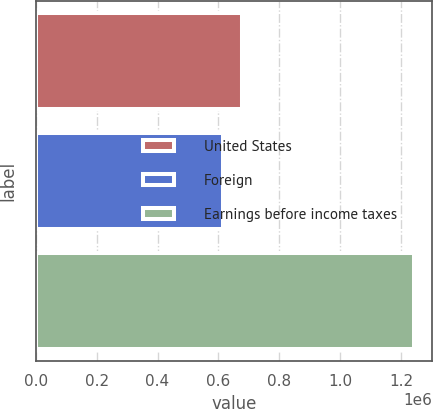Convert chart. <chart><loc_0><loc_0><loc_500><loc_500><bar_chart><fcel>United States<fcel>Foreign<fcel>Earnings before income taxes<nl><fcel>676315<fcel>613558<fcel>1.24112e+06<nl></chart> 